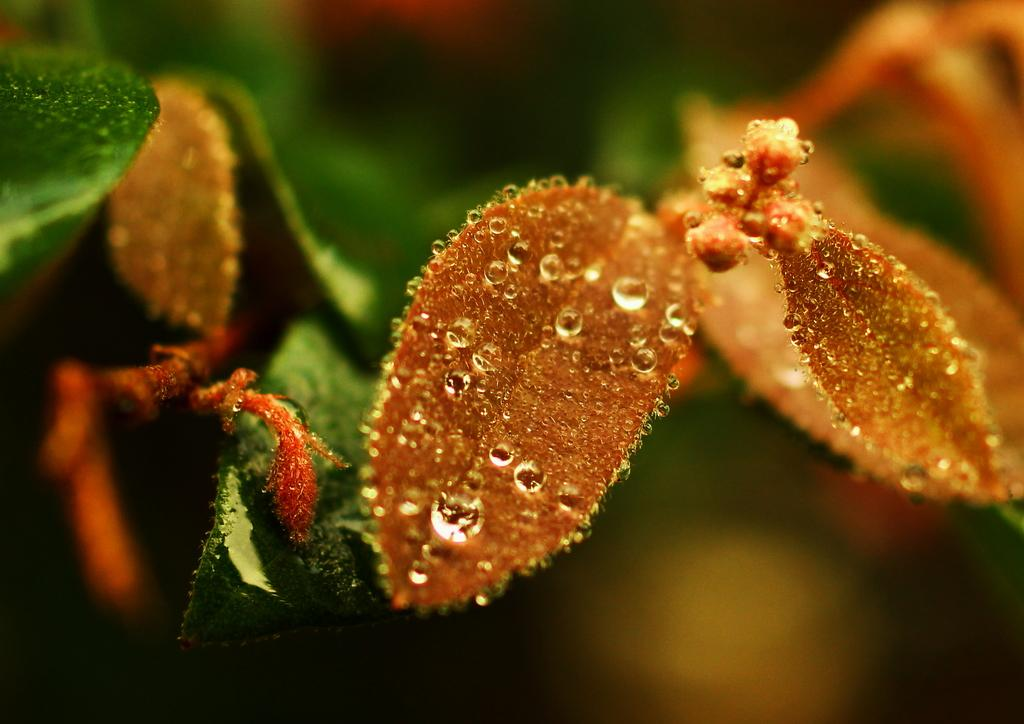What type of vegetation can be seen in the image? There are green leaves in the image. To which plant do the leaves belong? The leaves belong to a plant. What is present on the surface of the leaves? There are water drops on the leaves. What type of selection process is being used to choose the best leaf in the image? There is no selection process or indication of a best leaf in the image; it simply shows green leaves with water drops. 